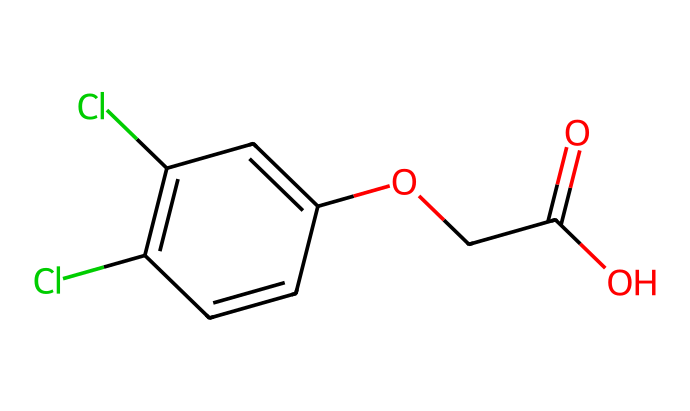What is the molecular formula of 2,4-D? By analyzing the chemical structure, we can count the number of carbon (C), hydrogen (H), chlorine (Cl), and oxygen (O) atoms present. In this case, there are 10 carbons, 11 hydrogens, 2 chlorines, and 4 oxygens. Therefore, the molecular formula is calculated as C10H11Cl2O4.
Answer: C10H11Cl2O4 How many chlorines are present in the molecular structure? The SMILES indicates two 'Cl' notations, which represent the presence of chlorine atoms. Therefore, by counting 'Cl' in the structure, we confirm there are 2 chlorine atoms.
Answer: 2 What functional groups are present in 2,4-D? Upon examining the structure, we can identify the carboxylic acid group (—COOH) and the ether group (—O—) connected to the aromatic ring. Thus, the main functional groups in the compound are carboxylic acid and ether.
Answer: carboxylic acid and ether What type of herbicide is 2,4-D classified as? 2,4-D is classified as a synthetic auxin, which mimics natural plant hormones. Its structure allows it to promote uncontrolled growth in broadleaf weeds, leading to their death, thus categorizing it as a herbicide.
Answer: synthetic auxin Does 2,4-D have a benzene ring in its structure? By examining the chemical backbone, we can see that part of the structure includes a six-membered carbon ring with alternating double bonds, characteristic of a benzene ring. Therefore, it is confirmed that a benzene ring is present.
Answer: yes What is the role of the carboxylic acid group in 2,4-D? The carboxylic acid group enhances the herbicide's solubility in water, facilitating its absorption by target plants and effectively interfering with their growth processes, contributing significantly to its herbicidal activity.
Answer: enhances solubility 